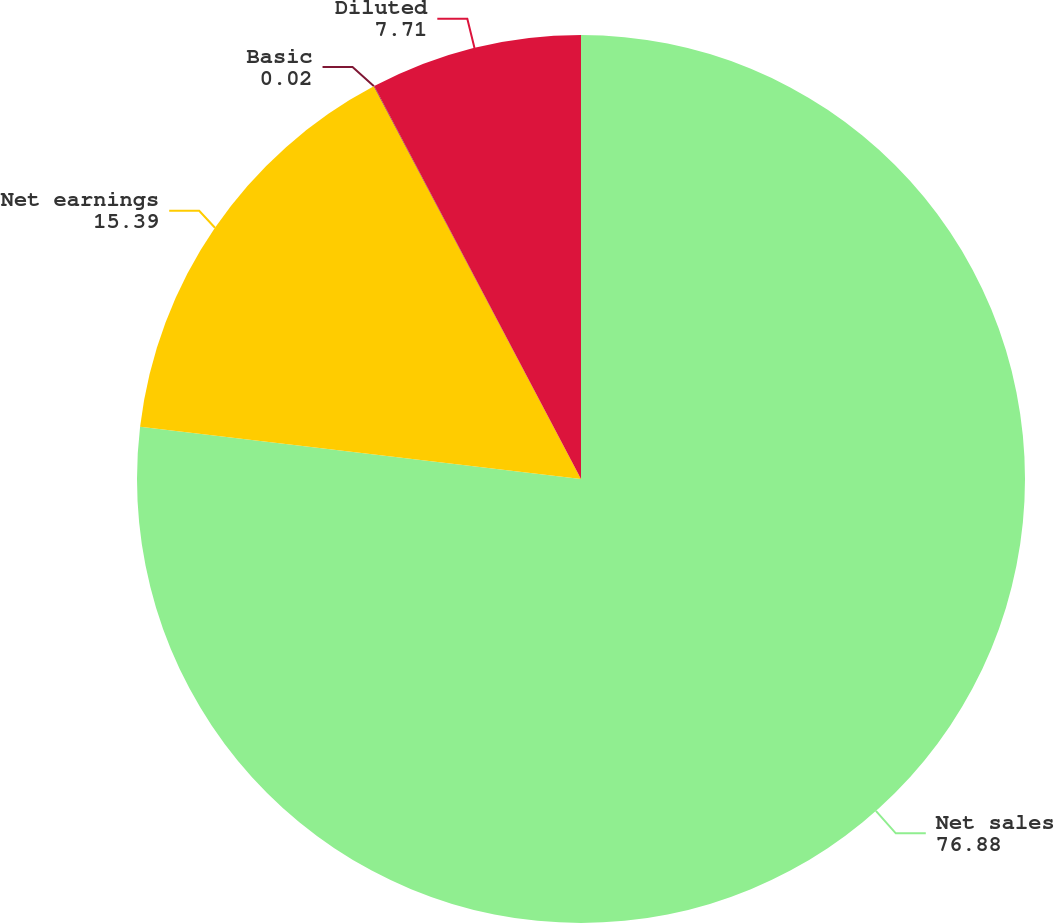<chart> <loc_0><loc_0><loc_500><loc_500><pie_chart><fcel>Net sales<fcel>Net earnings<fcel>Basic<fcel>Diluted<nl><fcel>76.88%<fcel>15.39%<fcel>0.02%<fcel>7.71%<nl></chart> 